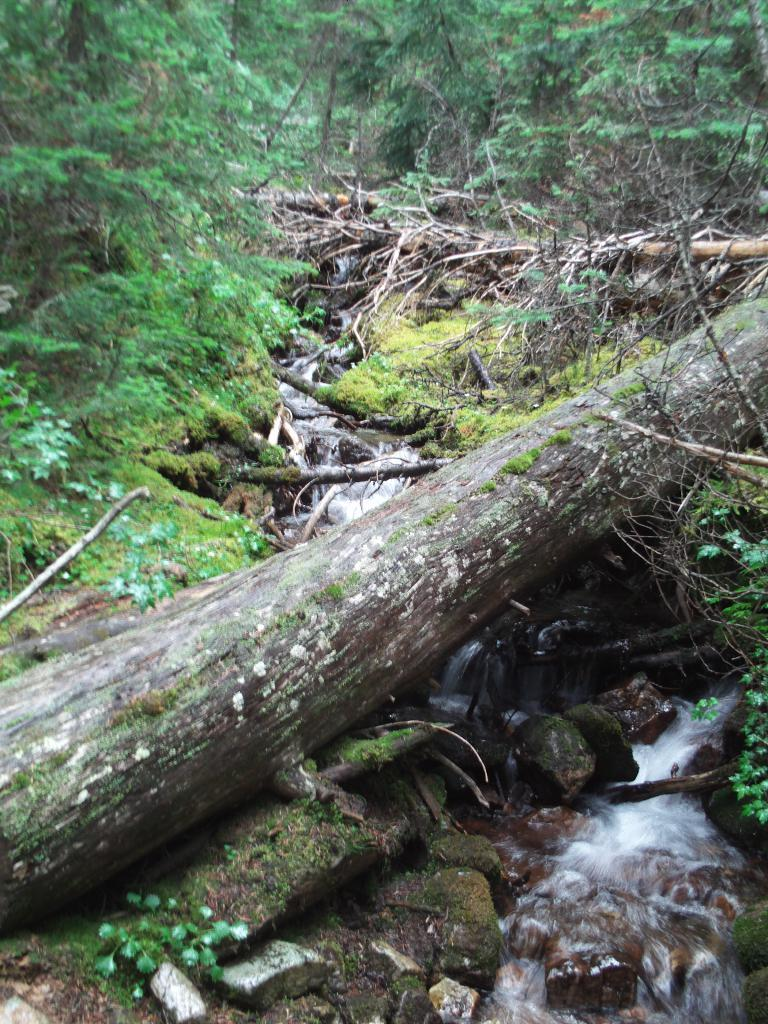What is the main object in the center of the image? There is a log in the center of the image. What natural feature can be seen at the bottom side of the image? There is a waterfall at the bottom side of the image. What type of environment is depicted in the image? There is greenery around the area of the image, suggesting a natural setting. What type of industry is depicted in the image? There is no industry present in the image; it features a log and a waterfall in a natural setting. Can you provide an example of someone laughing in the image? There is no one present in the image to laugh, as it depicts a log, a waterfall, and greenery in a natural setting. 